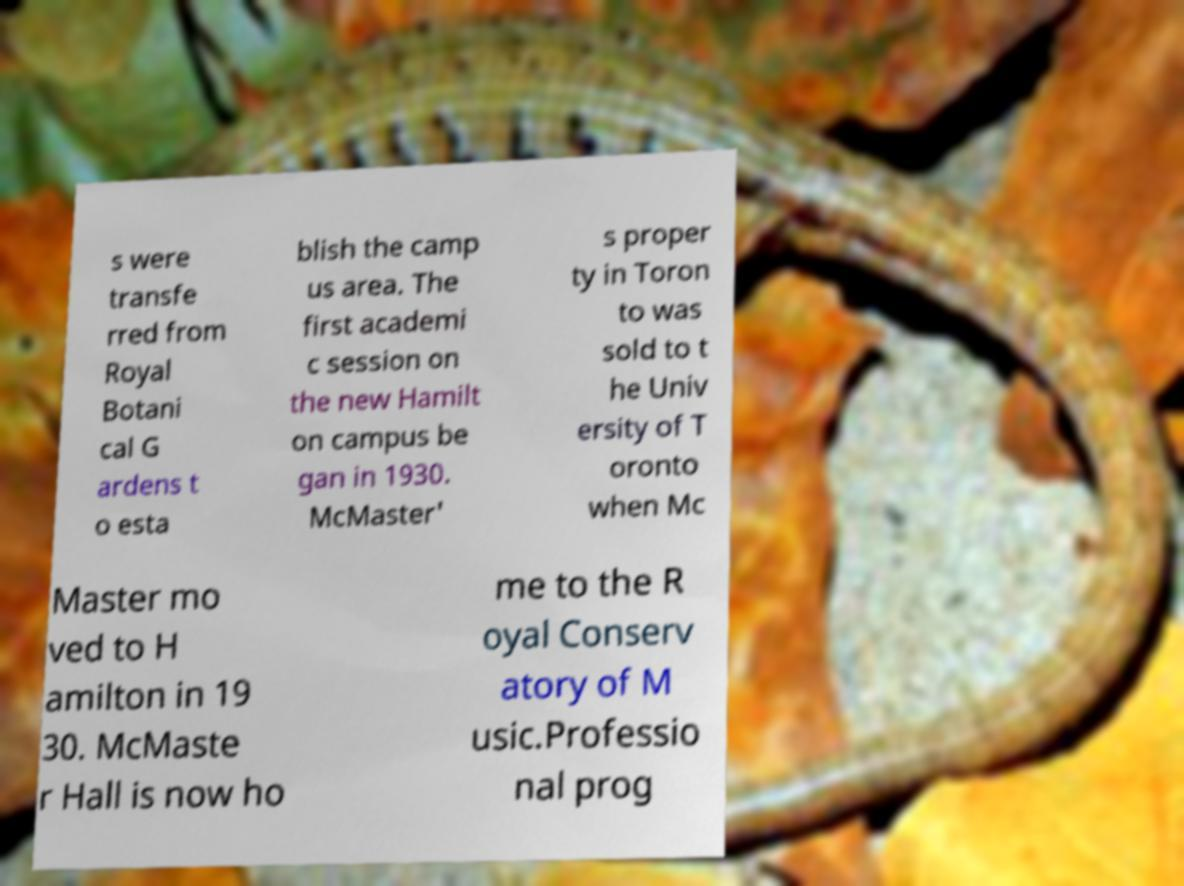What messages or text are displayed in this image? I need them in a readable, typed format. s were transfe rred from Royal Botani cal G ardens t o esta blish the camp us area. The first academi c session on the new Hamilt on campus be gan in 1930. McMaster' s proper ty in Toron to was sold to t he Univ ersity of T oronto when Mc Master mo ved to H amilton in 19 30. McMaste r Hall is now ho me to the R oyal Conserv atory of M usic.Professio nal prog 